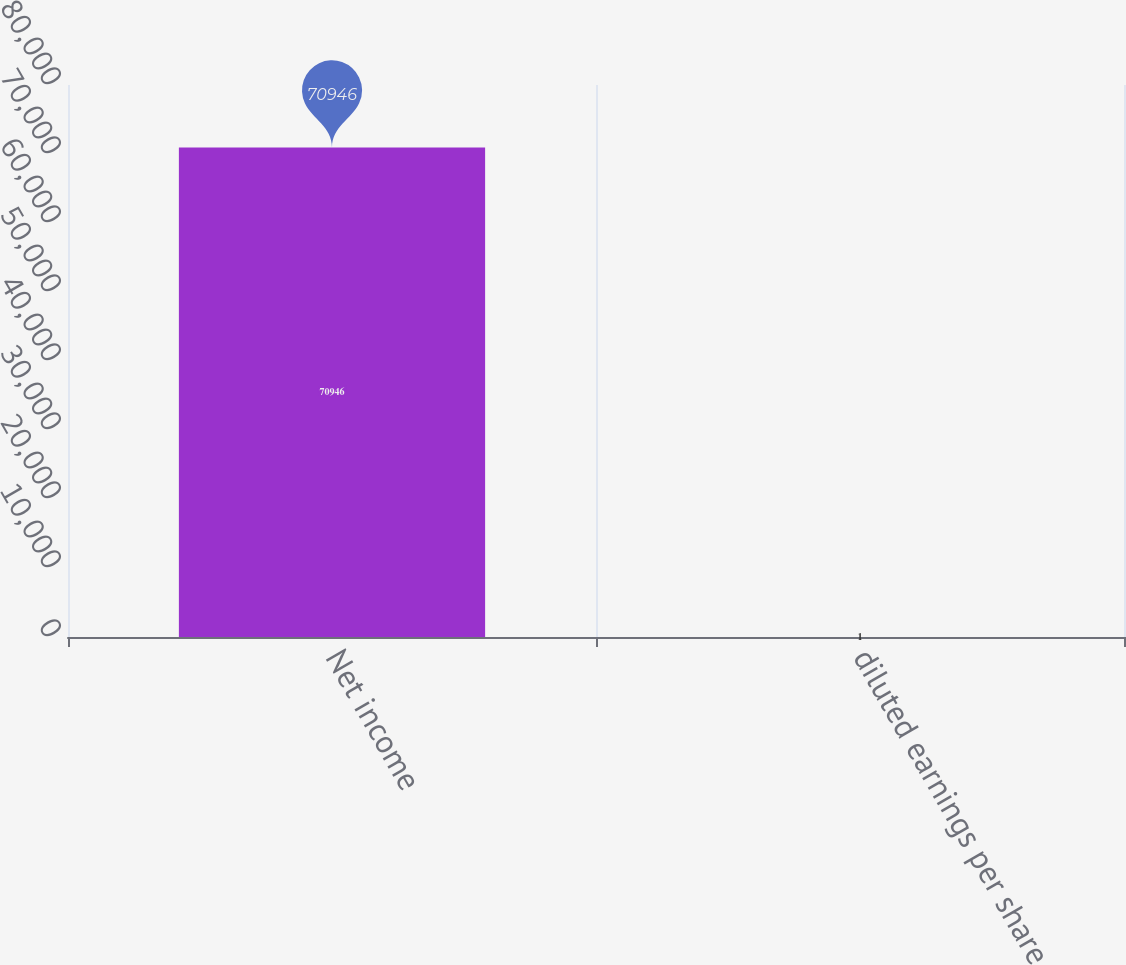<chart> <loc_0><loc_0><loc_500><loc_500><bar_chart><fcel>Net income<fcel>diluted earnings per share<nl><fcel>70946<fcel>1<nl></chart> 